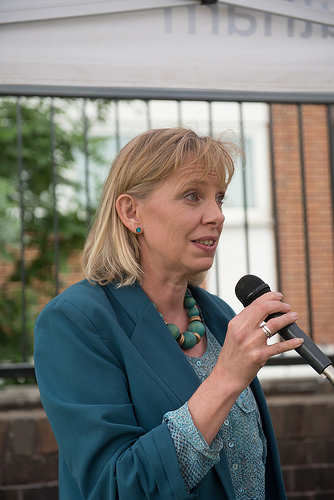<image>
Is there a mike to the left of the woman? No. The mike is not to the left of the woman. From this viewpoint, they have a different horizontal relationship. 